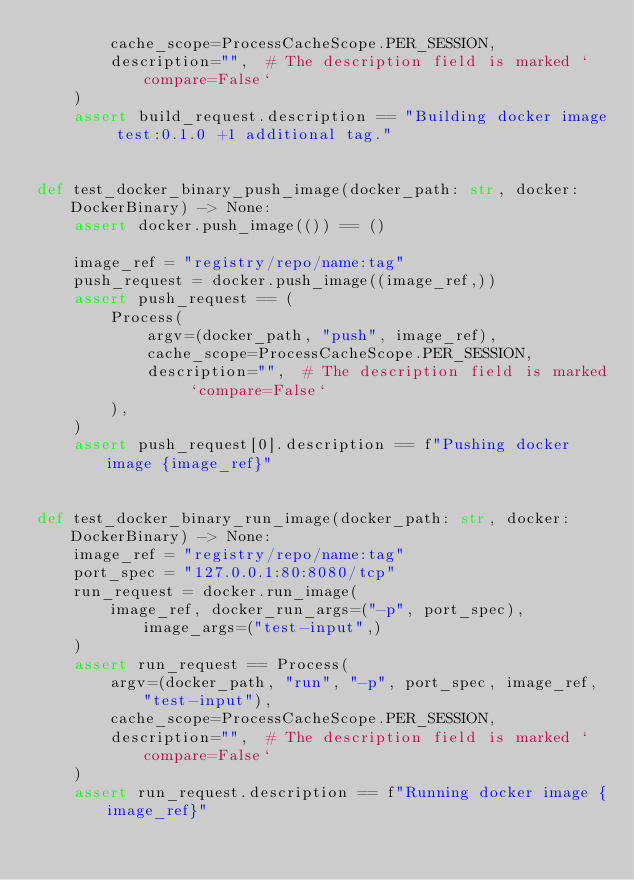<code> <loc_0><loc_0><loc_500><loc_500><_Python_>        cache_scope=ProcessCacheScope.PER_SESSION,
        description="",  # The description field is marked `compare=False`
    )
    assert build_request.description == "Building docker image test:0.1.0 +1 additional tag."


def test_docker_binary_push_image(docker_path: str, docker: DockerBinary) -> None:
    assert docker.push_image(()) == ()

    image_ref = "registry/repo/name:tag"
    push_request = docker.push_image((image_ref,))
    assert push_request == (
        Process(
            argv=(docker_path, "push", image_ref),
            cache_scope=ProcessCacheScope.PER_SESSION,
            description="",  # The description field is marked `compare=False`
        ),
    )
    assert push_request[0].description == f"Pushing docker image {image_ref}"


def test_docker_binary_run_image(docker_path: str, docker: DockerBinary) -> None:
    image_ref = "registry/repo/name:tag"
    port_spec = "127.0.0.1:80:8080/tcp"
    run_request = docker.run_image(
        image_ref, docker_run_args=("-p", port_spec), image_args=("test-input",)
    )
    assert run_request == Process(
        argv=(docker_path, "run", "-p", port_spec, image_ref, "test-input"),
        cache_scope=ProcessCacheScope.PER_SESSION,
        description="",  # The description field is marked `compare=False`
    )
    assert run_request.description == f"Running docker image {image_ref}"
</code> 